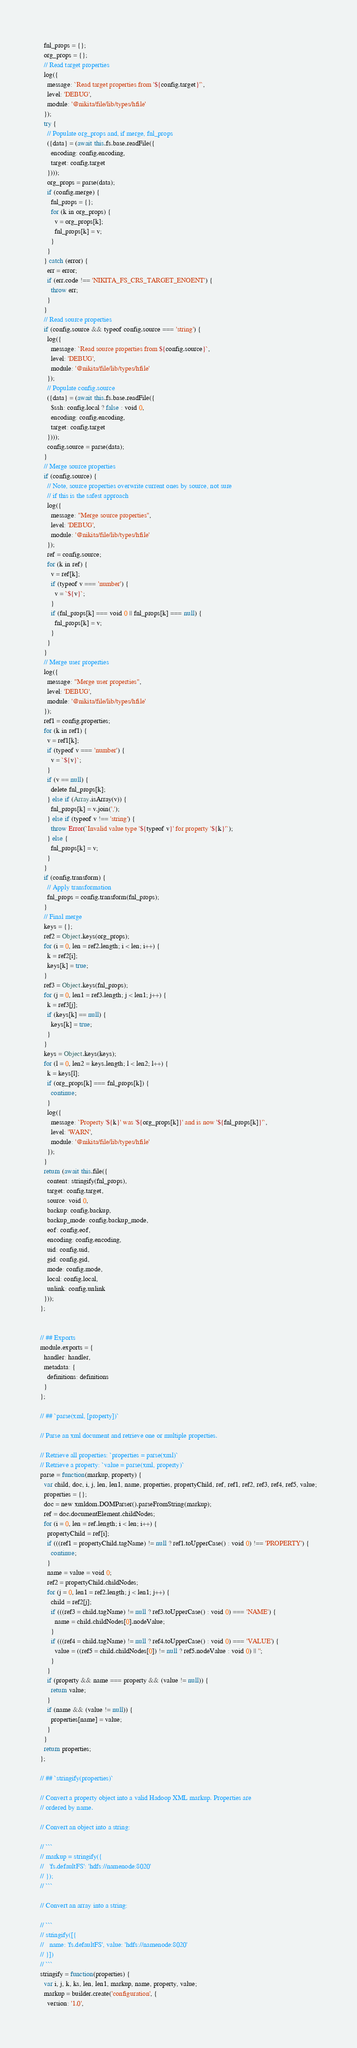Convert code to text. <code><loc_0><loc_0><loc_500><loc_500><_JavaScript_>  fnl_props = {};
  org_props = {};
  // Read target properties
  log({
    message: `Read target properties from '${config.target}'`,
    level: 'DEBUG',
    module: '@nikita/file/lib/types/hfile'
  });
  try {
    // Populate org_props and, if merge, fnl_props
    ({data} = (await this.fs.base.readFile({
      encoding: config.encoding,
      target: config.target
    })));
    org_props = parse(data);
    if (config.merge) {
      fnl_props = {};
      for (k in org_props) {
        v = org_props[k];
        fnl_props[k] = v;
      }
    }
  } catch (error) {
    err = error;
    if (err.code !== 'NIKITA_FS_CRS_TARGET_ENOENT') {
      throw err;
    }
  }
  // Read source properties
  if (config.source && typeof config.source === 'string') {
    log({
      message: `Read source properties from ${config.source}`,
      level: 'DEBUG',
      module: '@nikita/file/lib/types/hfile'
    });
    // Populate config.source
    ({data} = (await this.fs.base.readFile({
      $ssh: config.local ? false : void 0,
      encoding: config.encoding,
      target: config.target
    })));
    config.source = parse(data);
  }
  // Merge source properties
  if (config.source) {
    // Note, source properties overwrite current ones by source, not sure
    // if this is the safest approach
    log({
      message: "Merge source properties",
      level: 'DEBUG',
      module: '@nikita/file/lib/types/hfile'
    });
    ref = config.source;
    for (k in ref) {
      v = ref[k];
      if (typeof v === 'number') {
        v = `${v}`;
      }
      if (fnl_props[k] === void 0 || fnl_props[k] === null) {
        fnl_props[k] = v;
      }
    }
  }
  // Merge user properties
  log({
    message: "Merge user properties",
    level: 'DEBUG',
    module: '@nikita/file/lib/types/hfile'
  });
  ref1 = config.properties;
  for (k in ref1) {
    v = ref1[k];
    if (typeof v === 'number') {
      v = `${v}`;
    }
    if (v == null) {
      delete fnl_props[k];
    } else if (Array.isArray(v)) {
      fnl_props[k] = v.join(',');
    } else if (typeof v !== 'string') {
      throw Error(`Invalid value type '${typeof v}' for property '${k}'`);
    } else {
      fnl_props[k] = v;
    }
  }
  if (config.transform) {
    // Apply transformation
    fnl_props = config.transform(fnl_props);
  }
  // Final merge
  keys = {};
  ref2 = Object.keys(org_props);
  for (i = 0, len = ref2.length; i < len; i++) {
    k = ref2[i];
    keys[k] = true;
  }
  ref3 = Object.keys(fnl_props);
  for (j = 0, len1 = ref3.length; j < len1; j++) {
    k = ref3[j];
    if (keys[k] == null) {
      keys[k] = true;
    }
  }
  keys = Object.keys(keys);
  for (l = 0, len2 = keys.length; l < len2; l++) {
    k = keys[l];
    if (org_props[k] === fnl_props[k]) {
      continue;
    }
    log({
      message: `Property '${k}' was '${org_props[k]}' and is now '${fnl_props[k]}'`,
      level: 'WARN',
      module: '@nikita/file/lib/types/hfile'
    });
  }
  return (await this.file({
    content: stringify(fnl_props),
    target: config.target,
    source: void 0,
    backup: config.backup,
    backup_mode: config.backup_mode,
    eof: config.eof,
    encoding: config.encoding,
    uid: config.uid,
    gid: config.gid,
    mode: config.mode,
    local: config.local,
    unlink: config.unlink
  }));
};


// ## Exports
module.exports = {
  handler: handler,
  metadata: {
    definitions: definitions
  }
};

// ## `parse(xml, [property])`

// Parse an xml document and retrieve one or multiple properties.

// Retrieve all properties: `properties = parse(xml)`
// Retrieve a property: `value = parse(xml, property)`
parse = function(markup, property) {
  var child, doc, i, j, len, len1, name, properties, propertyChild, ref, ref1, ref2, ref3, ref4, ref5, value;
  properties = {};
  doc = new xmldom.DOMParser().parseFromString(markup);
  ref = doc.documentElement.childNodes;
  for (i = 0, len = ref.length; i < len; i++) {
    propertyChild = ref[i];
    if (((ref1 = propertyChild.tagName) != null ? ref1.toUpperCase() : void 0) !== 'PROPERTY') {
      continue;
    }
    name = value = void 0;
    ref2 = propertyChild.childNodes;
    for (j = 0, len1 = ref2.length; j < len1; j++) {
      child = ref2[j];
      if (((ref3 = child.tagName) != null ? ref3.toUpperCase() : void 0) === 'NAME') {
        name = child.childNodes[0].nodeValue;
      }
      if (((ref4 = child.tagName) != null ? ref4.toUpperCase() : void 0) === 'VALUE') {
        value = ((ref5 = child.childNodes[0]) != null ? ref5.nodeValue : void 0) || '';
      }
    }
    if (property && name === property && (value != null)) {
      return value;
    }
    if (name && (value != null)) {
      properties[name] = value;
    }
  }
  return properties;
};

// ## `stringify(properties)`

// Convert a property object into a valid Hadoop XML markup. Properties are
// ordered by name.

// Convert an object into a string:

// ```
// markup = stringify({
//   'fs.defaultFS': 'hdfs://namenode:8020'
// });
// ```

// Convert an array into a string:

// ```
// stringify([{
//   name: 'fs.defaultFS', value: 'hdfs://namenode:8020'
// }])
// ```
stringify = function(properties) {
  var i, j, k, ks, len, len1, markup, name, property, value;
  markup = builder.create('configuration', {
    version: '1.0',</code> 